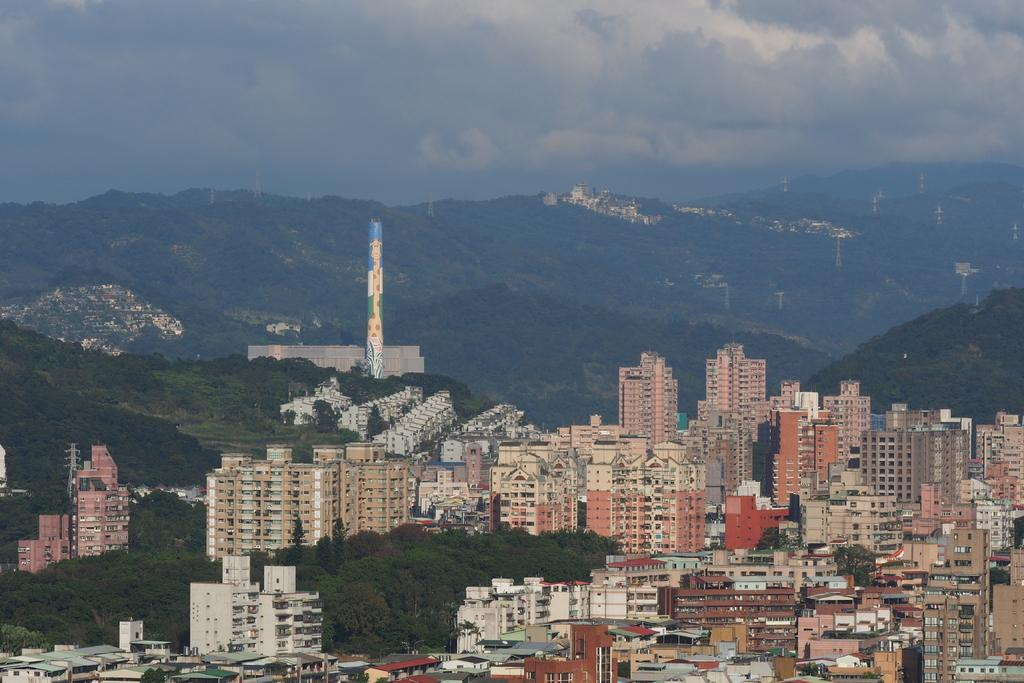What type of structures can be seen in the image? There are buildings in the image. What other natural elements are present in the image? There are trees in the image. What can be seen in the distance in the image? There are hills visible in the background of the image. What is visible in the sky in the image? The sky is visible in the background of the image. What type of account is being managed by the government in the image? There is no mention of an account or government in the image; it features buildings, trees, hills, and the sky. 